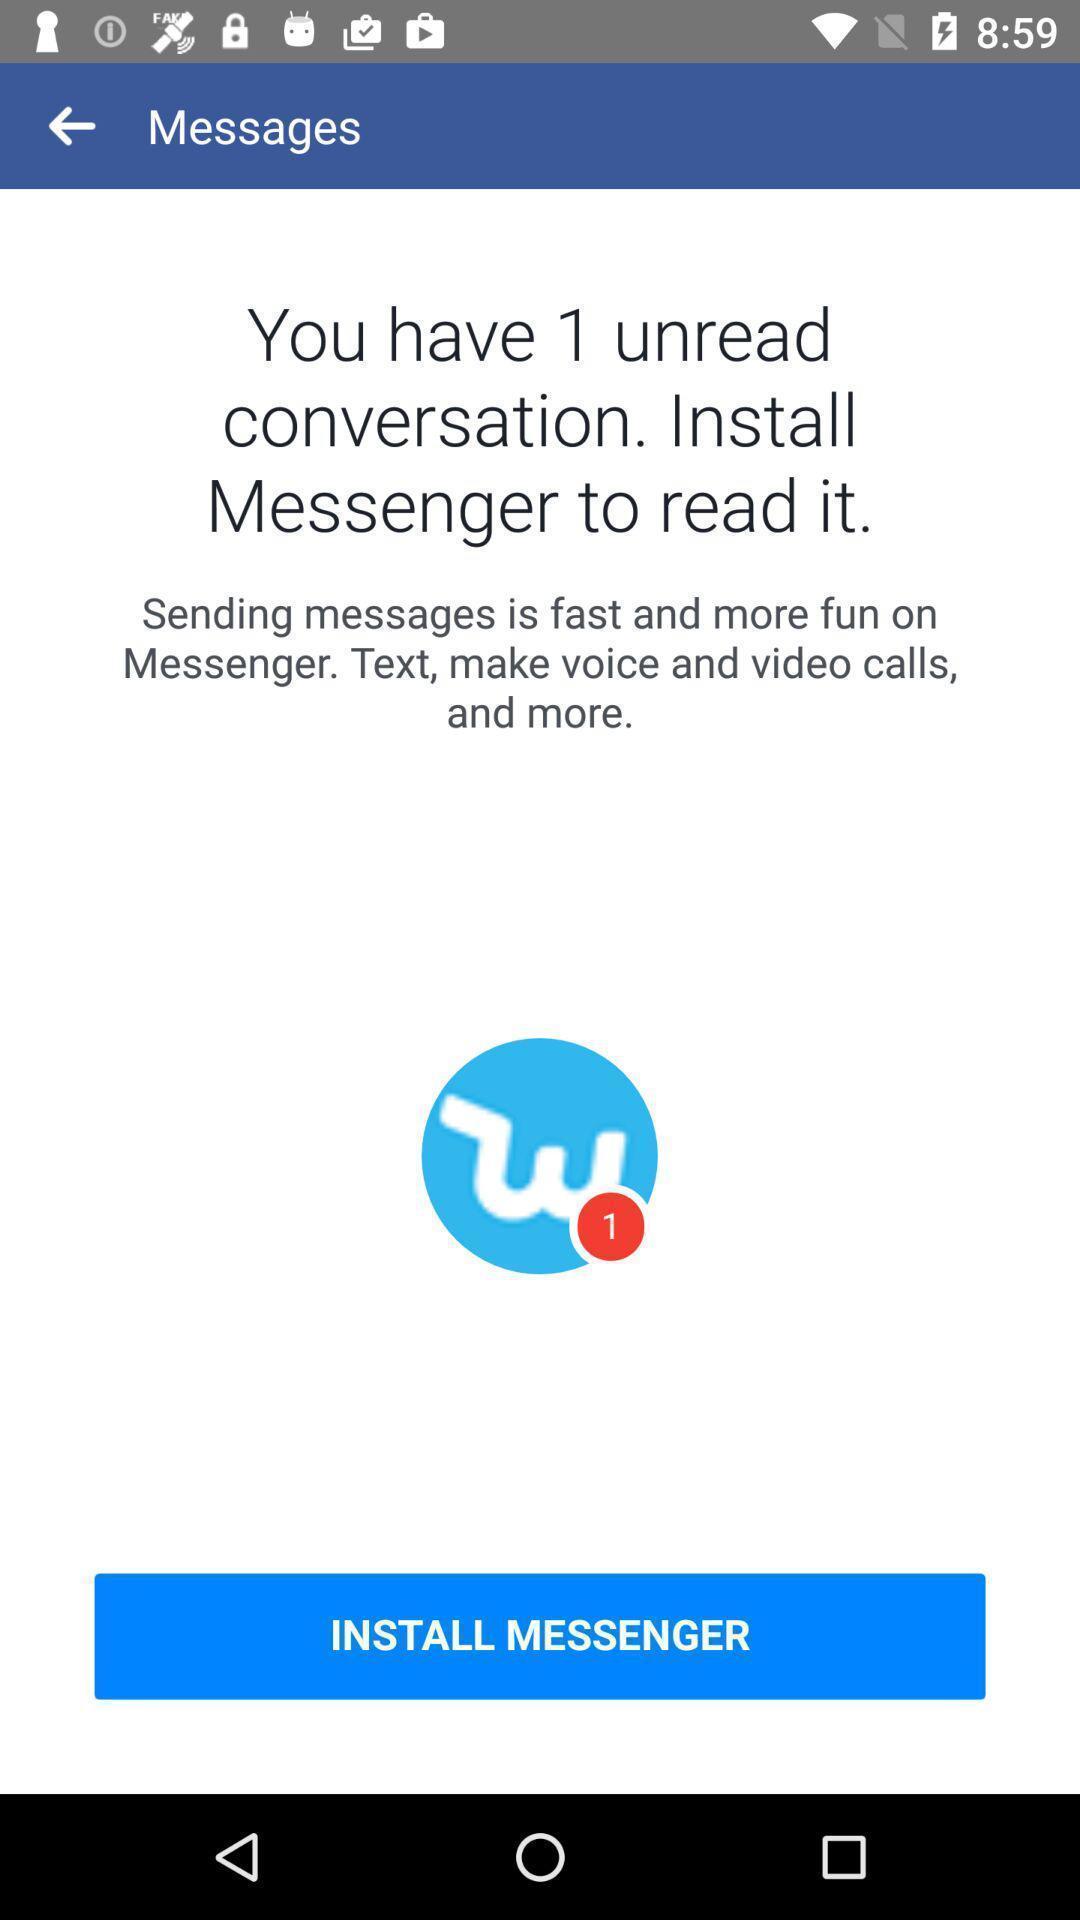What is the overall content of this screenshot? Page to download the social messaging app. 